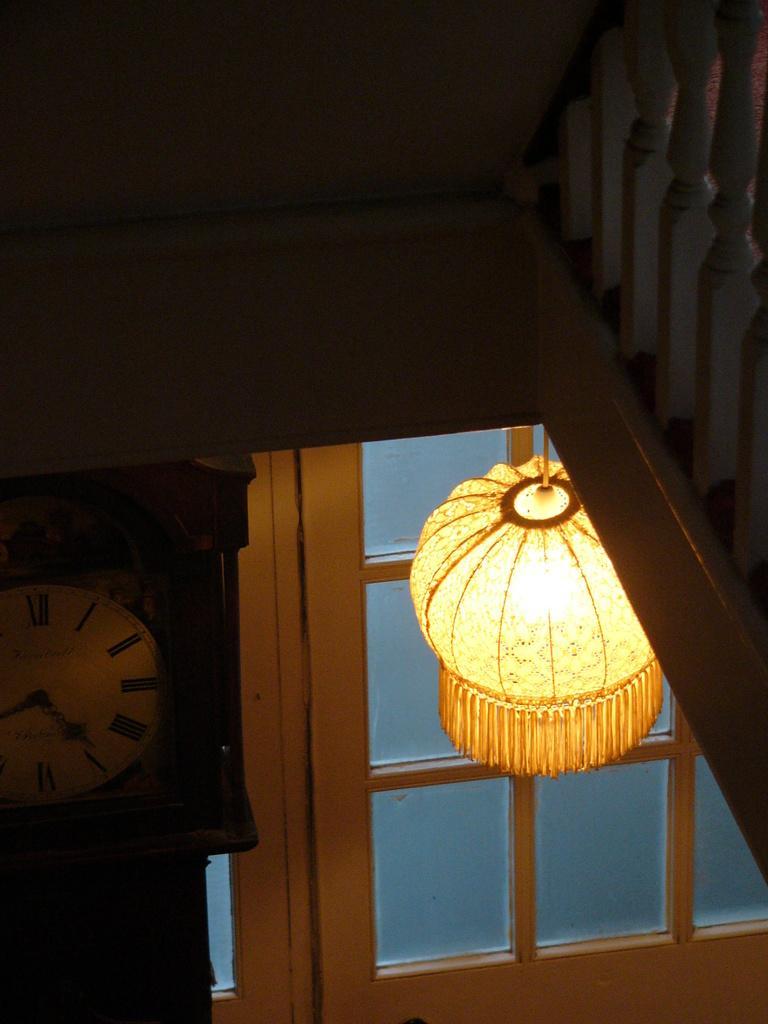Please provide a concise description of this image. On the right side there is a railing. On the left side there is a clock. In the back there is a door. Near to that there is a light. 